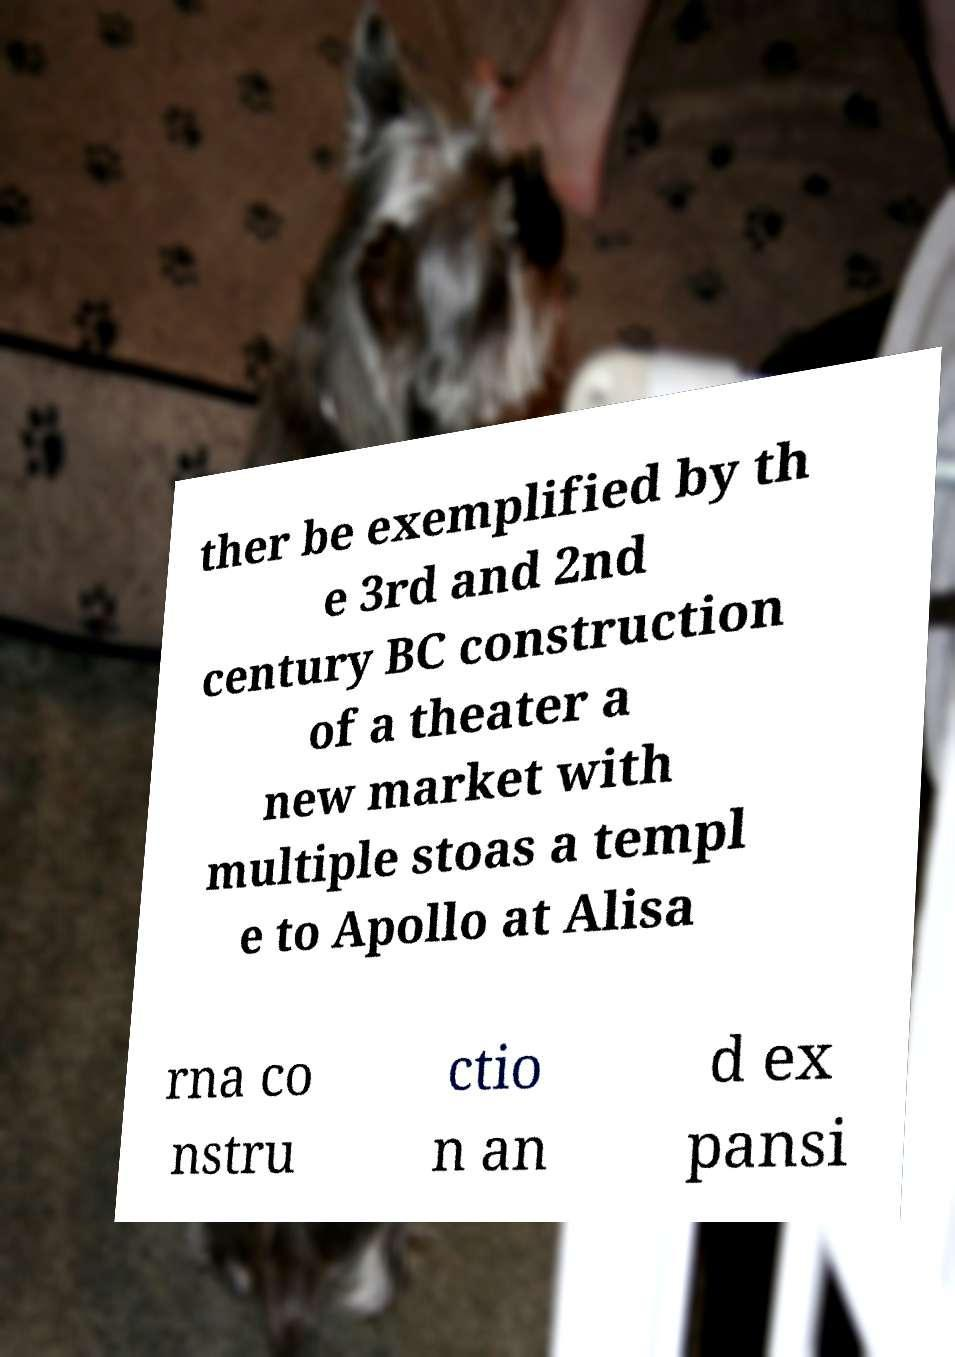What messages or text are displayed in this image? I need them in a readable, typed format. ther be exemplified by th e 3rd and 2nd century BC construction of a theater a new market with multiple stoas a templ e to Apollo at Alisa rna co nstru ctio n an d ex pansi 